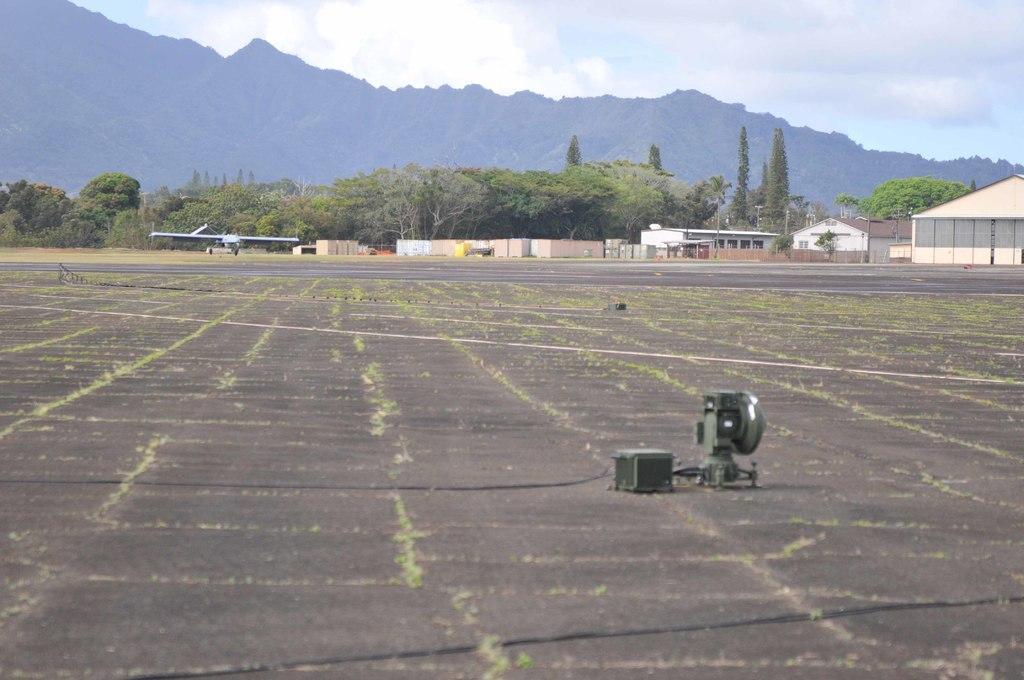How would you summarize this image in a sentence or two? In this picture I can see few houses, trees and hills and a cloudy sky and I can see a machine on the ground and looks like a jet plane in the back. 